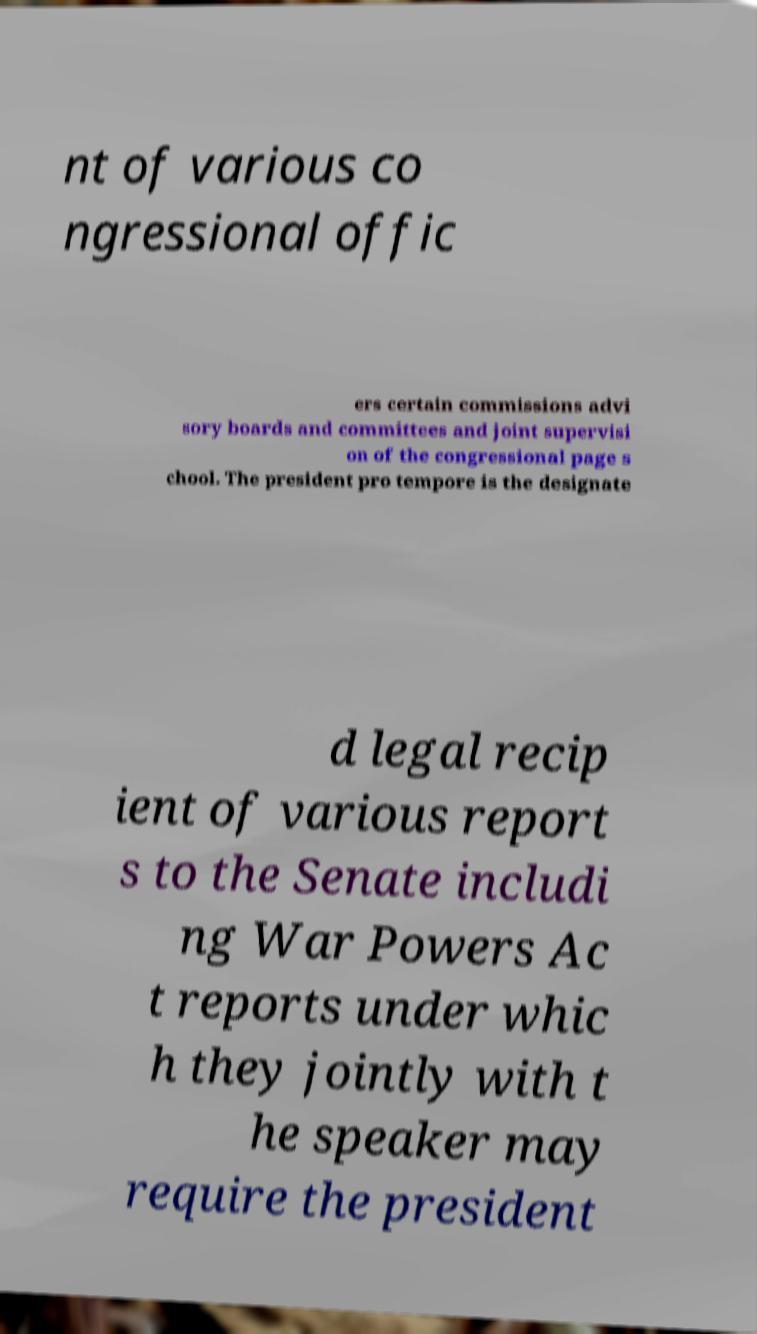Can you accurately transcribe the text from the provided image for me? nt of various co ngressional offic ers certain commissions advi sory boards and committees and joint supervisi on of the congressional page s chool. The president pro tempore is the designate d legal recip ient of various report s to the Senate includi ng War Powers Ac t reports under whic h they jointly with t he speaker may require the president 